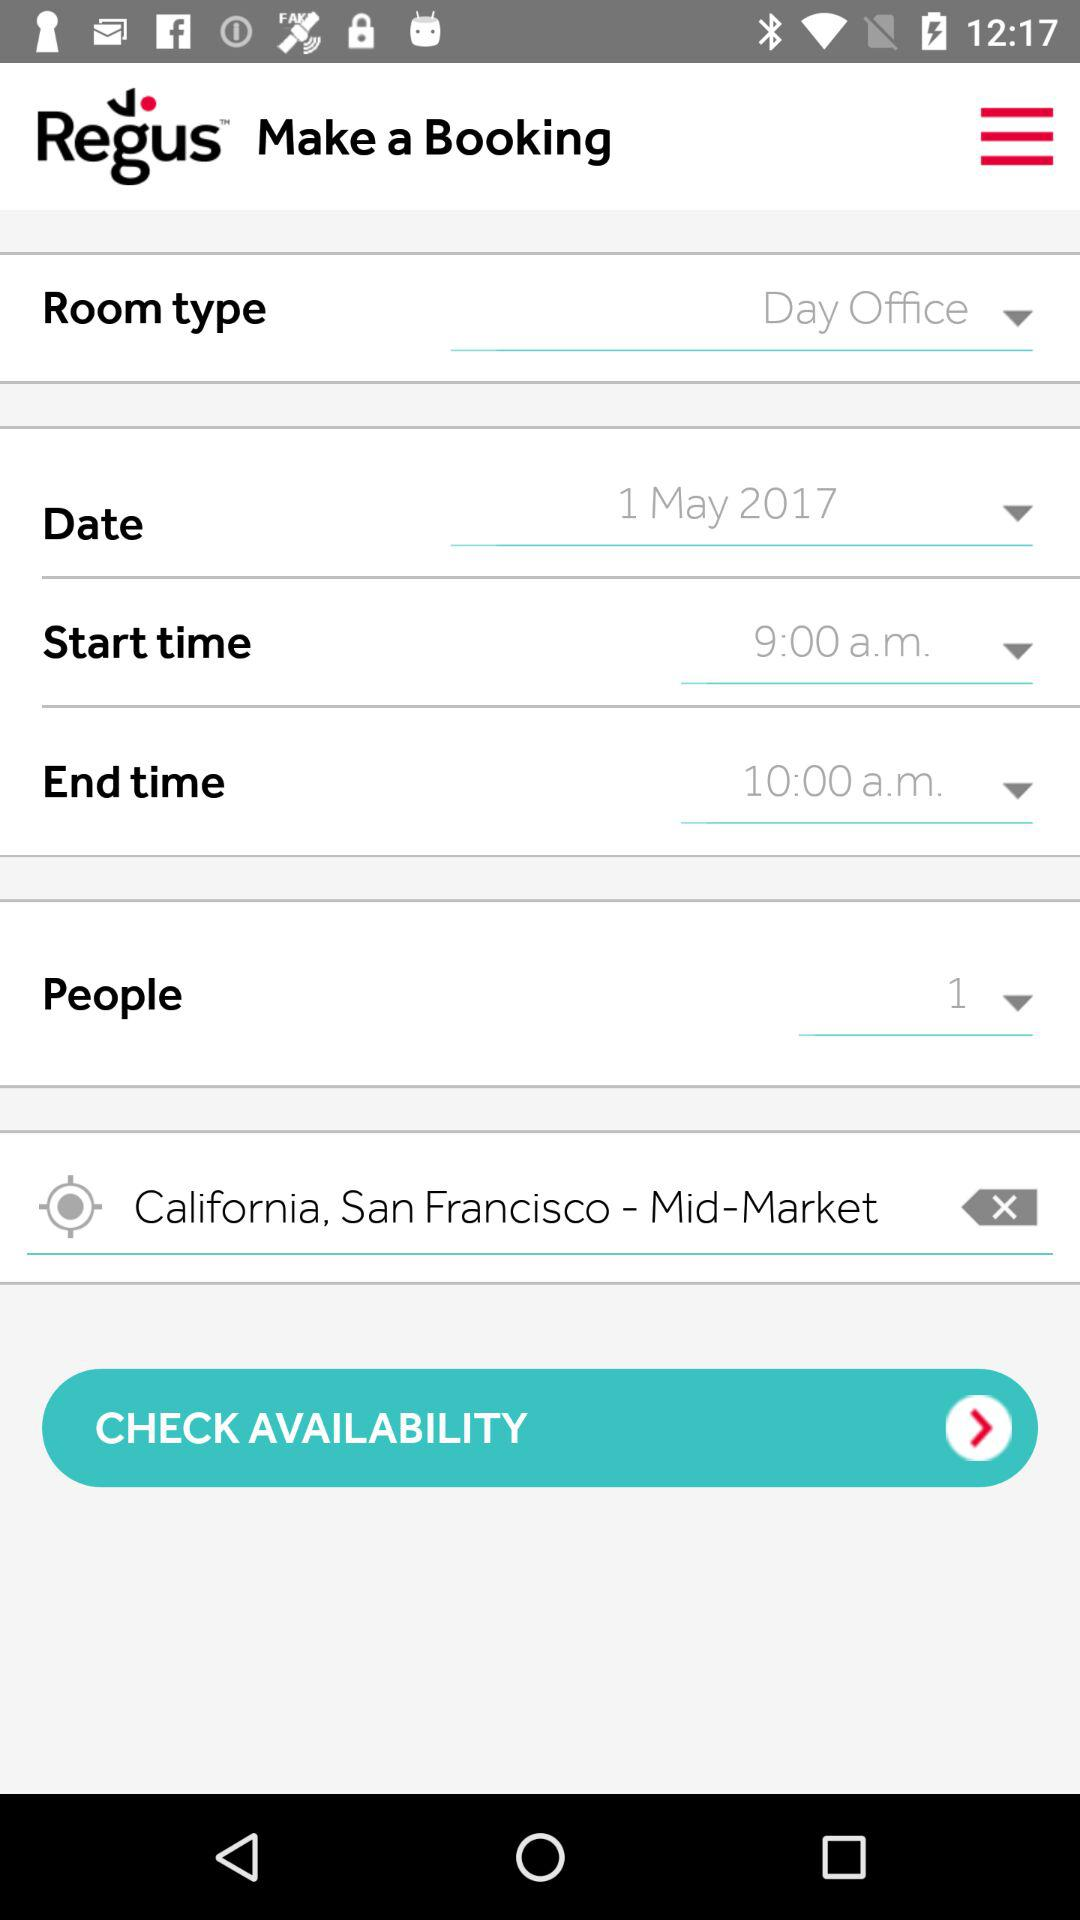What is the mentioned date? The mentioned date is May 1, 2017. 